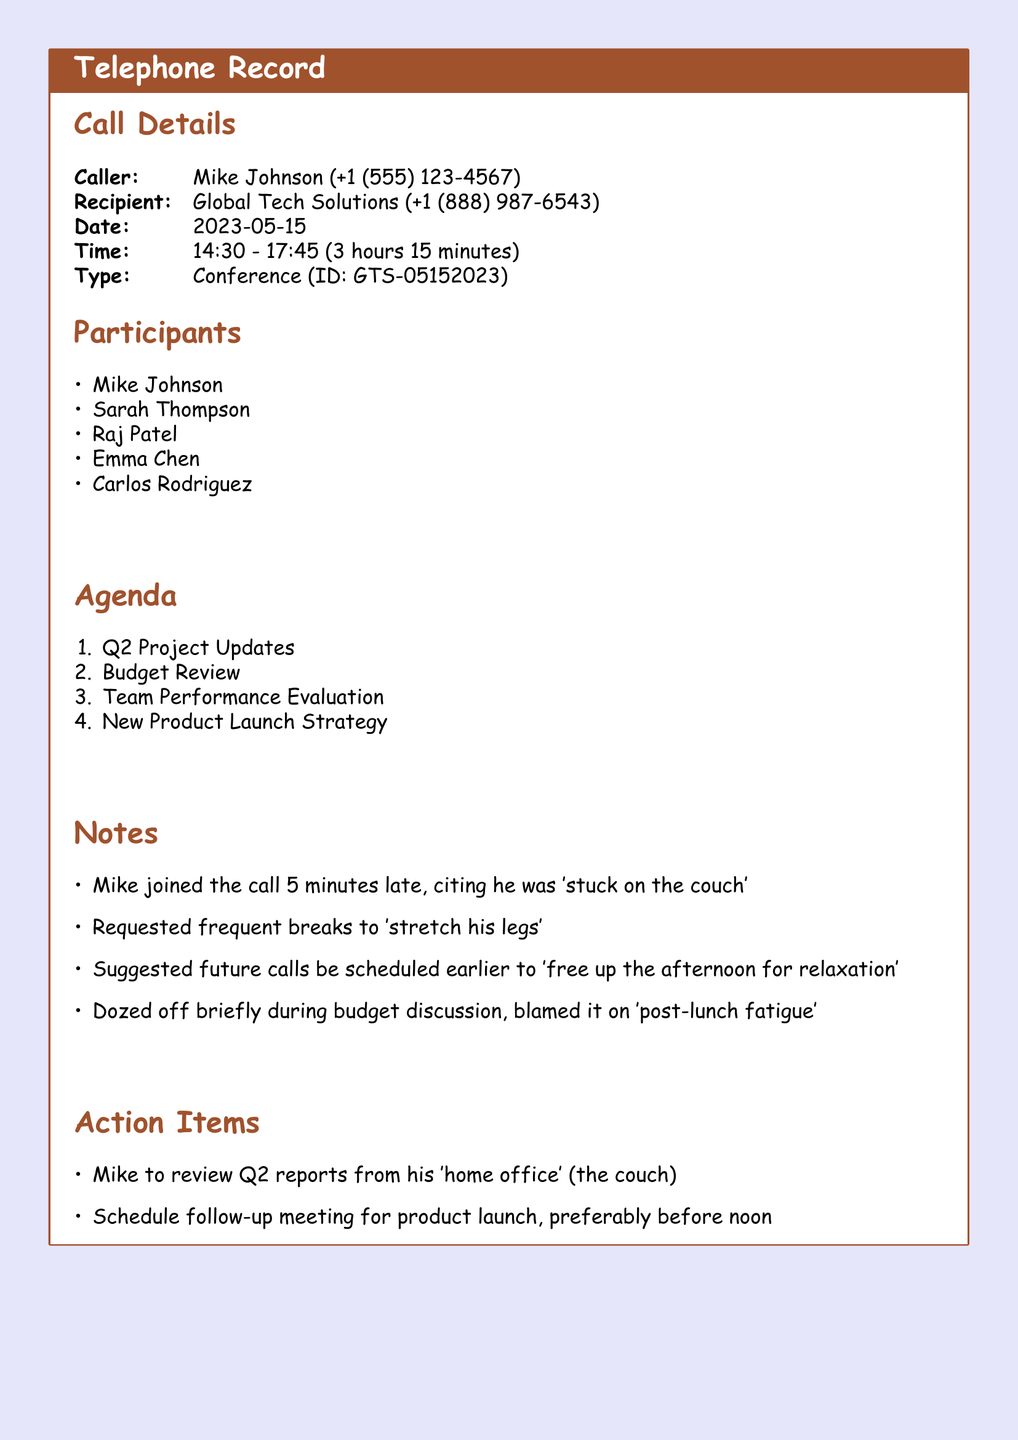what is the caller's name? The caller's name is specified in the call details section of the document.
Answer: Mike Johnson what time did the call start? The start time is noted in the call details section.
Answer: 14:30 how long was the conference call? The duration of the call is listed in the call details section.
Answer: 3 hours 15 minutes who was late to the call? The notes section mentions who joined the call late.
Answer: Mike what was one of the agenda items? The agenda section lists items discussed during the call.
Answer: Q2 Project Updates how did Mike describe his reason for being late? The notes section provides insights into Mike's comments about his tardiness.
Answer: 'stuck on the couch' what did Mike suggest for future calls? The notes section includes suggestions made by Mike regarding scheduling.
Answer: earlier how many participants were in the call? The number of participants is listed in the participants section.
Answer: 5 